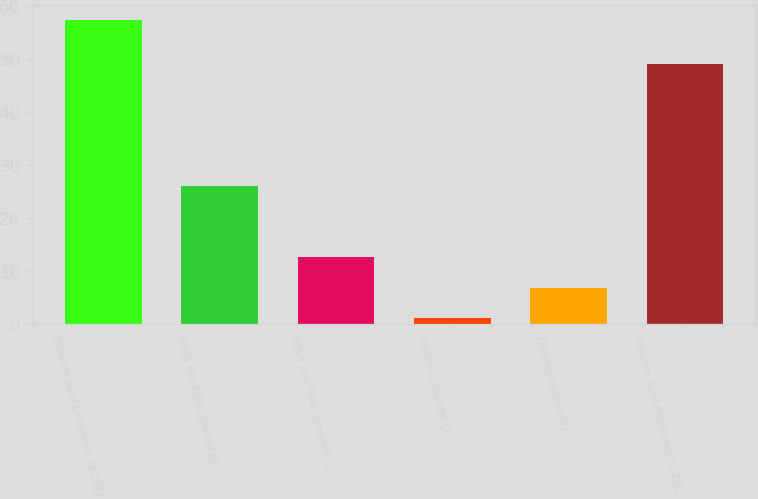Convert chart to OTSL. <chart><loc_0><loc_0><loc_500><loc_500><bar_chart><fcel>Balance as of December 31 2012<fcel>RSUs and PSAs granted (1)<fcel>RSUs and PSAs canceled (1)<fcel>Options canceled (2)<fcel>Options expired (2)<fcel>Balance as of December 31 2013<nl><fcel>57.3<fcel>26.1<fcel>12.6<fcel>1.2<fcel>6.81<fcel>49.1<nl></chart> 